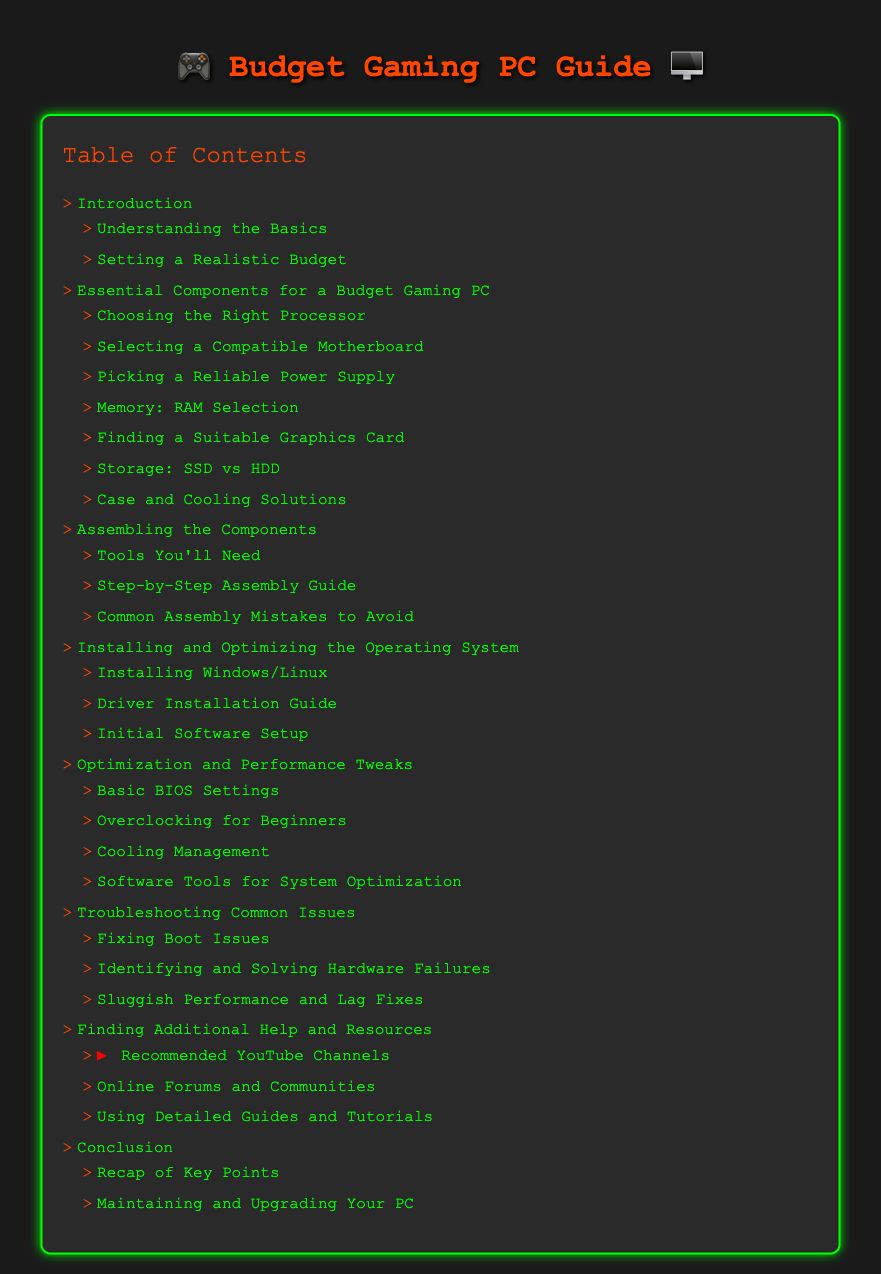What is the first section of the document? The first section of the document is the "Introduction," which is listed in the Table of Contents.
Answer: Introduction How many sub-sections are in the "Essential Components for a Budget Gaming PC" section? The "Essential Components for a Budget Gaming PC" section has six sub-sections, as indicated in the Table of Contents.
Answer: 6 What tool category is mentioned in the "Assembling the Components"? The "Assembling the Components" section includes "Tools You'll Need" as a sub-section.
Answer: Tools What is the last optimization topic covered in the document? The last optimization topic in the "Optimization and Performance Tweaks" section is "Software Tools for System Optimization."
Answer: Software Tools for System Optimization Which section covers common computer issues? The section that deals with common computer issues is "Troubleshooting Common Issues."
Answer: Troubleshooting Common Issues What is suggested for additional help and resources? The document suggests "Recommended YouTube Channels" for additional help and resources.
Answer: Recommended YouTube Channels What does the conclusion section recap? The conclusion section recaps "Key Points."
Answer: Key Points How many main sections are there in the document? The document has seven main sections listed in the Table of Contents.
Answer: 7 What type of operating systems does the document mention installing? The document mentions installing Windows or Linux in the "Installing and Optimizing the Operating System" section.
Answer: Windows/Linux 